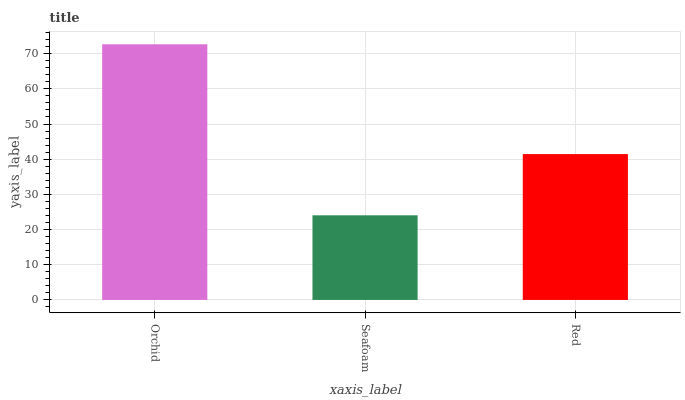Is Seafoam the minimum?
Answer yes or no. Yes. Is Orchid the maximum?
Answer yes or no. Yes. Is Red the minimum?
Answer yes or no. No. Is Red the maximum?
Answer yes or no. No. Is Red greater than Seafoam?
Answer yes or no. Yes. Is Seafoam less than Red?
Answer yes or no. Yes. Is Seafoam greater than Red?
Answer yes or no. No. Is Red less than Seafoam?
Answer yes or no. No. Is Red the high median?
Answer yes or no. Yes. Is Red the low median?
Answer yes or no. Yes. Is Seafoam the high median?
Answer yes or no. No. Is Seafoam the low median?
Answer yes or no. No. 